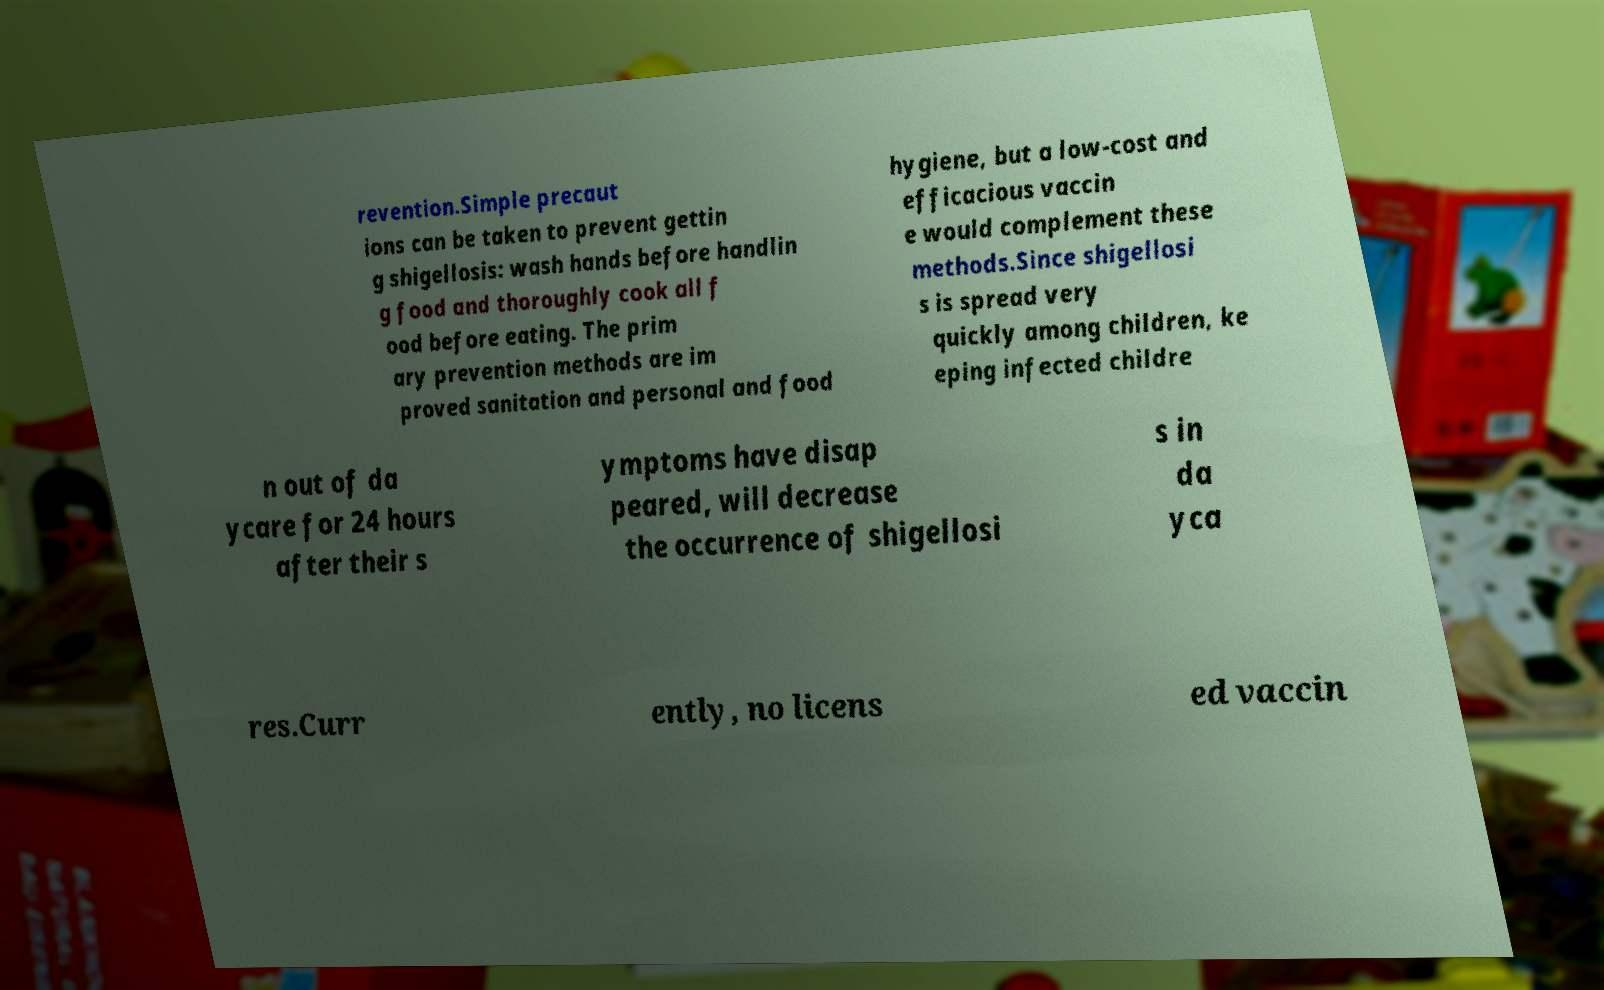There's text embedded in this image that I need extracted. Can you transcribe it verbatim? revention.Simple precaut ions can be taken to prevent gettin g shigellosis: wash hands before handlin g food and thoroughly cook all f ood before eating. The prim ary prevention methods are im proved sanitation and personal and food hygiene, but a low-cost and efficacious vaccin e would complement these methods.Since shigellosi s is spread very quickly among children, ke eping infected childre n out of da ycare for 24 hours after their s ymptoms have disap peared, will decrease the occurrence of shigellosi s in da yca res.Curr ently, no licens ed vaccin 